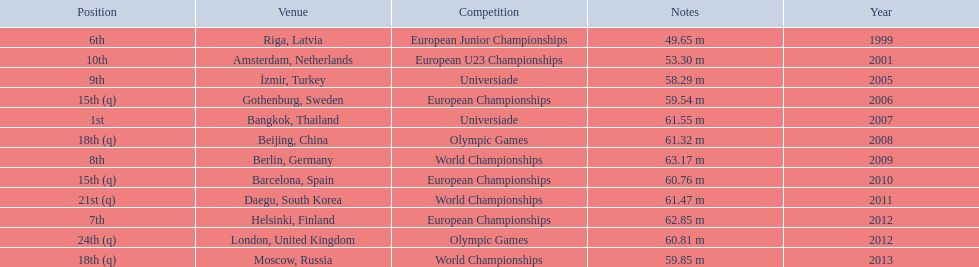What are all the competitions? European Junior Championships, European U23 Championships, Universiade, European Championships, Universiade, Olympic Games, World Championships, European Championships, World Championships, European Championships, Olympic Games, World Championships. What years did they place in the top 10? 1999, 2001, 2005, 2007, 2009, 2012. Besides when they placed first, which position was their highest? 6th. 